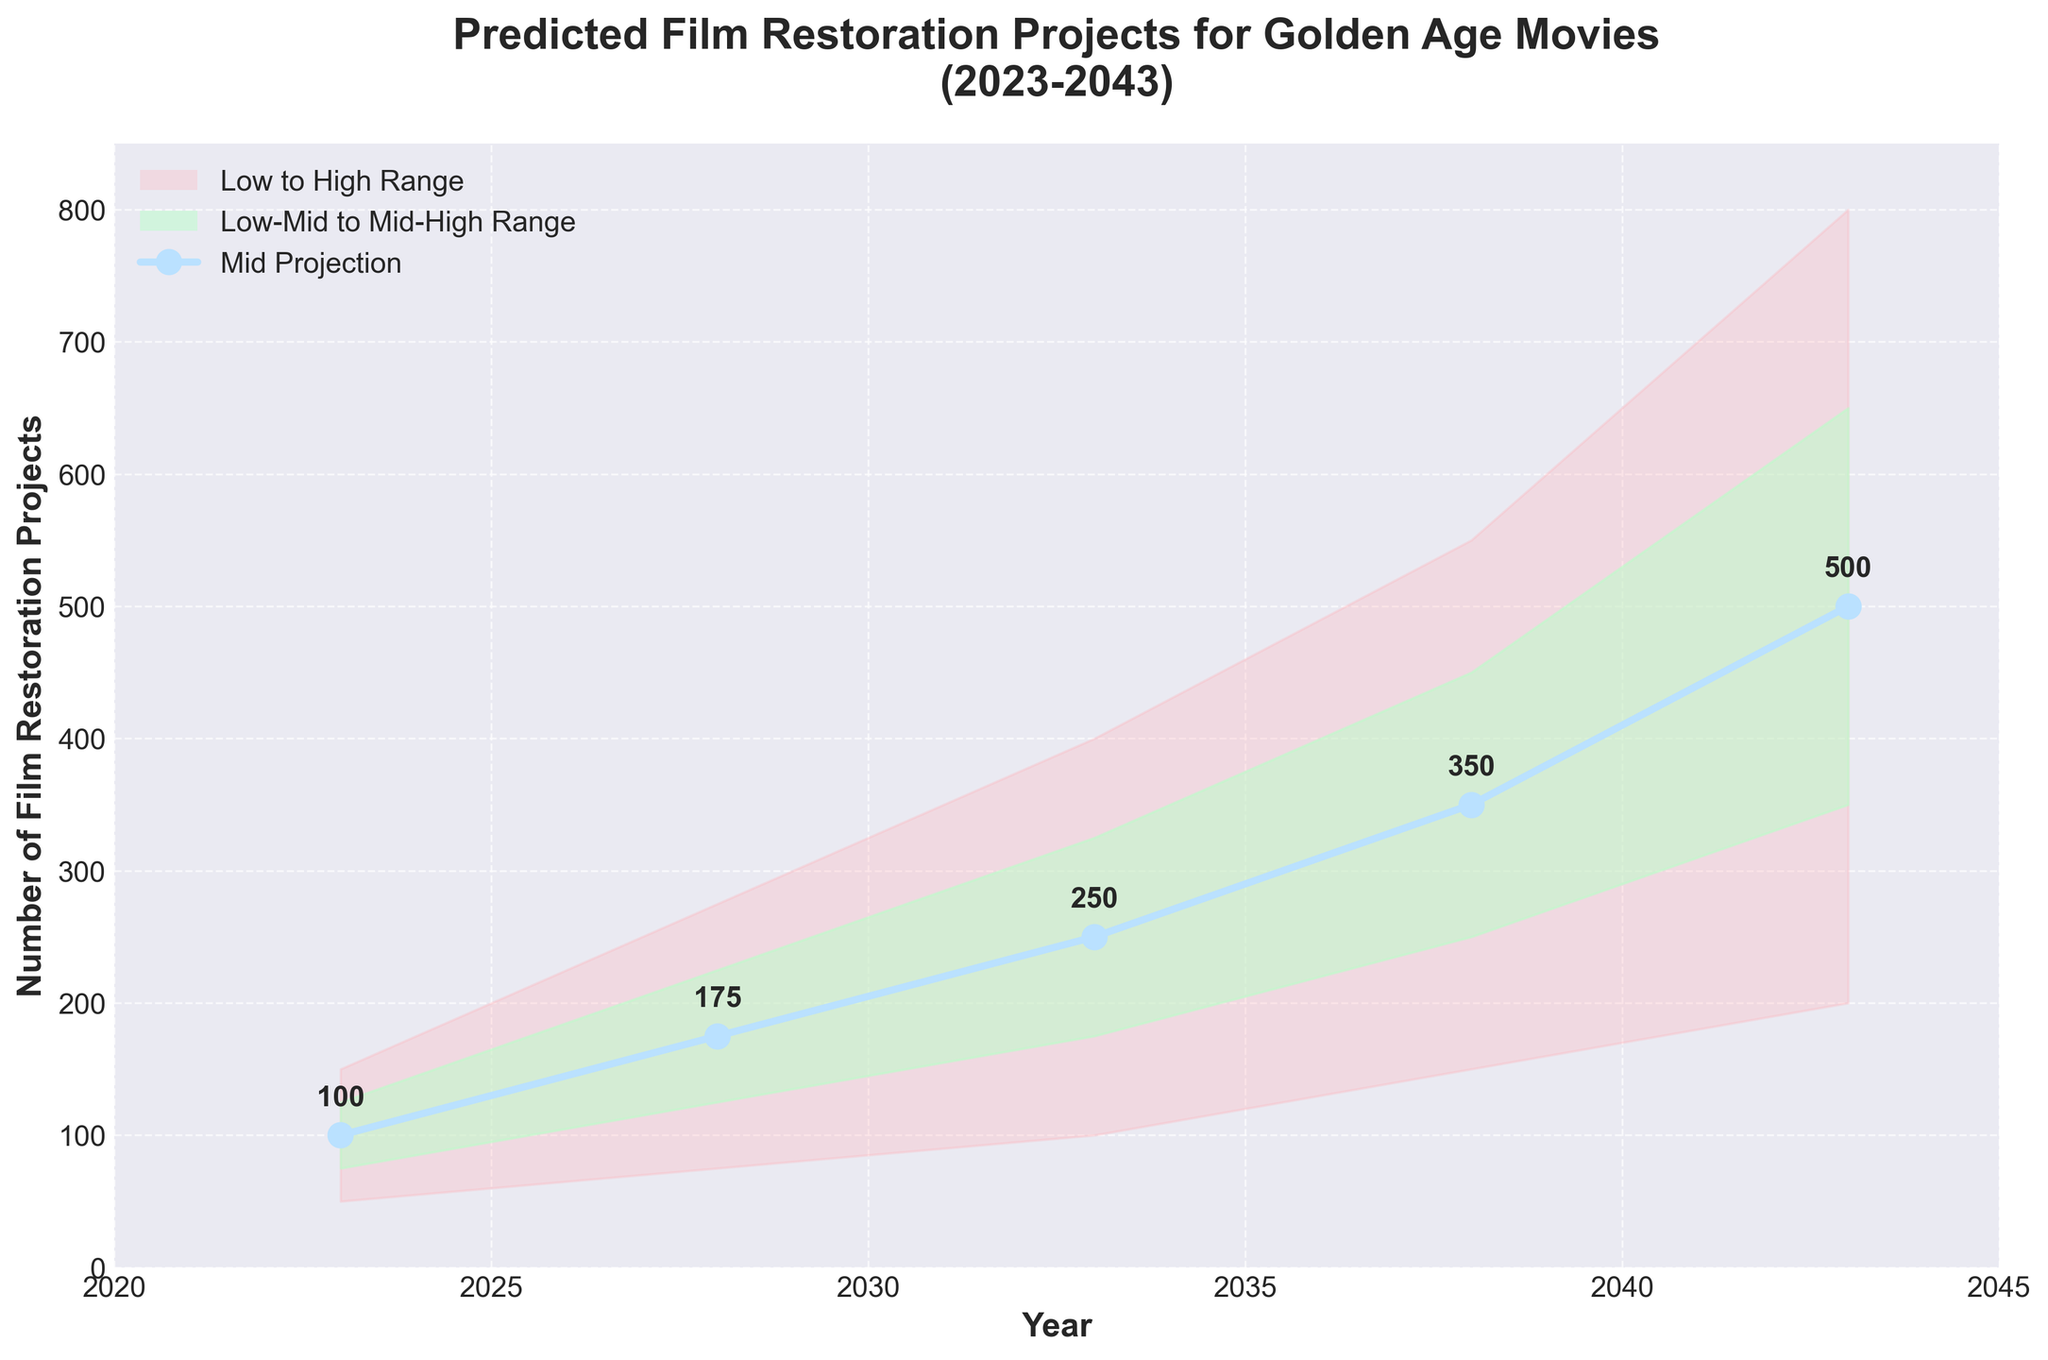What years are displayed on the x-axis? The x-axis shows years ranging from 2023 to 2043, incrementing every 5 years (2023, 2028, 2033, 2038, 2043).
Answer: 2023 to 2043 What is the predicted mid value of film restoration projects in 2038? Referring to the plot, the mid value in the year 2038 is annotated as 350.
Answer: 350 In what year is the high prediction for film restoration projects expected to reach 800? The plot shows that the high value reaches 800 in the year 2043.
Answer: 2043 What is the range of predicted film restoration projects in 2028? The range is from the Low value to the High value. In 2028, this range is from 75 to 275.
Answer: 75 to 275 How does the mid value change from 2023 to 2043? The mid value in 2023 is 100, and in 2043 it's 500. The change is 500 - 100 = 400.
Answer: 400 Comparing 2023 and 2033, in which year is the mid-high value greater? The mid-high value for 2023 is 125, and for 2033 it is 325. Comparing these values, 2033 has the greater mid-high value.
Answer: 2033 What’s the average number of mid projections across all displayed years? Sum of mid values (100, 175, 250, 350, 500) is 1375, and there are 5 data points, so the average is 1375 / 5
Answer: 275 What's the lowest number of the predicted low-mid range in the plot? The lowest number in the Low-Mid range at any year is in 2023, which is 75.
Answer: 75 Between 2033 and 2043, by how much does the low prediction increase? The low prediction in 2033 is 100, and in 2043 it's 200. The increase is 200 - 100 = 100.
Answer: 100 What's the difference between the low and high predictions in 2023? The low prediction is 50 and the high prediction is 150. The difference is 150 - 50 = 100.
Answer: 100 